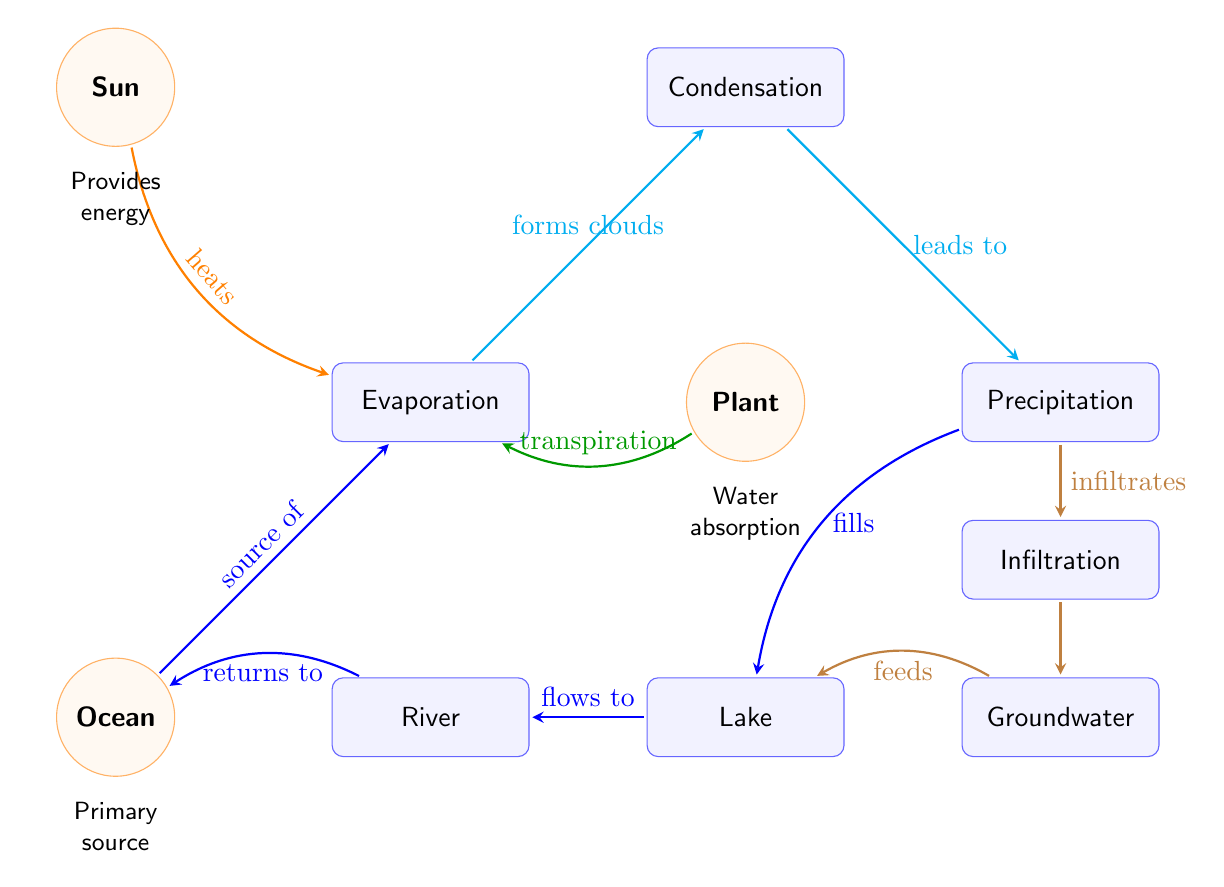What process is directly influenced by the Sun? The Sun provides energy, which directly influences the Evaporation process.
Answer: Evaporation How many sources are depicted in the diagram? There are two sources shown in the diagram: the Sun and the Ocean.
Answer: 2 Which process leads to precipitation? The process of Condensation leads to Precipitation.
Answer: Condensation What process is responsible for returning water to the Ocean? The River process is responsible for returning water to the Ocean through flow.
Answer: River What natural process contributes to the formation of clouds? The Evaporation process contributes to the formation of clouds.
Answer: Evaporation What happens to water after it precipitates? After precipitation, water either infiltrates into the ground or fills the Lake.
Answer: Fills or Infiltrates How does groundwater interact with the Lake? Groundwater feeds the Lake, supplying additional water.
Answer: Feeds Which process describes water movement from plants into the atmosphere? The process of Transpiration describes water movement from plants into the atmosphere.
Answer: Transpiration What is the main source for the Evaporation process? The Ocean is the main source for the Evaporation process.
Answer: Ocean 